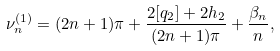<formula> <loc_0><loc_0><loc_500><loc_500>\nu _ { n } ^ { ( 1 ) } = ( 2 n + 1 ) \pi + \frac { 2 [ q _ { 2 } ] + 2 h _ { 2 } } { ( 2 n + 1 ) \pi } + \frac { \beta _ { n } } { n } ,</formula> 